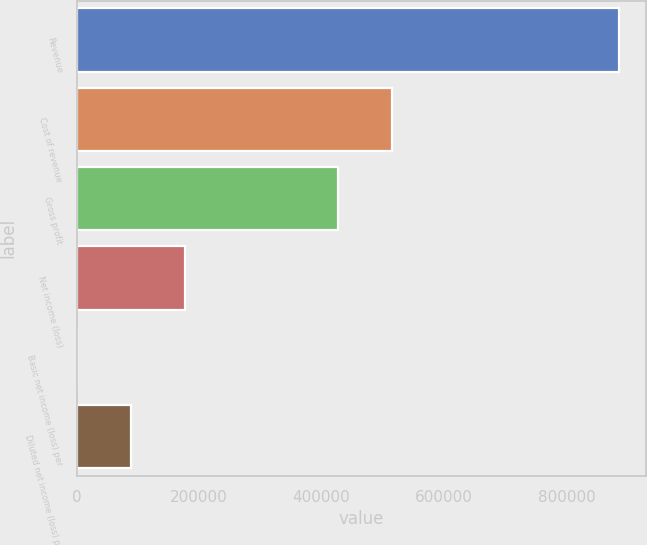Convert chart to OTSL. <chart><loc_0><loc_0><loc_500><loc_500><bar_chart><fcel>Revenue<fcel>Cost of revenue<fcel>Gross profit<fcel>Net income (loss)<fcel>Basic net income (loss) per<fcel>Diluted net income (loss) per<nl><fcel>886376<fcel>514997<fcel>426359<fcel>177275<fcel>0.29<fcel>88637.9<nl></chart> 